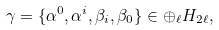Convert formula to latex. <formula><loc_0><loc_0><loc_500><loc_500>\gamma = \{ \alpha ^ { 0 } , \alpha ^ { i } , \beta _ { i } , \beta _ { 0 } \} \in \oplus _ { \ell } H _ { 2 \ell } ,</formula> 